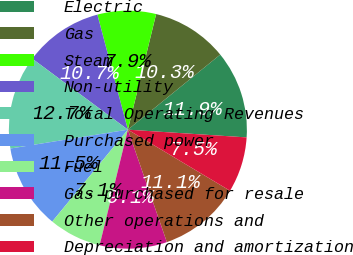Convert chart to OTSL. <chart><loc_0><loc_0><loc_500><loc_500><pie_chart><fcel>Electric<fcel>Gas<fcel>Steam<fcel>Non-utility<fcel>Total Operating Revenues<fcel>Purchased power<fcel>Fuel<fcel>Gas purchased for resale<fcel>Other operations and<fcel>Depreciation and amortization<nl><fcel>11.9%<fcel>10.32%<fcel>7.94%<fcel>10.71%<fcel>12.7%<fcel>11.51%<fcel>7.14%<fcel>9.13%<fcel>11.11%<fcel>7.54%<nl></chart> 